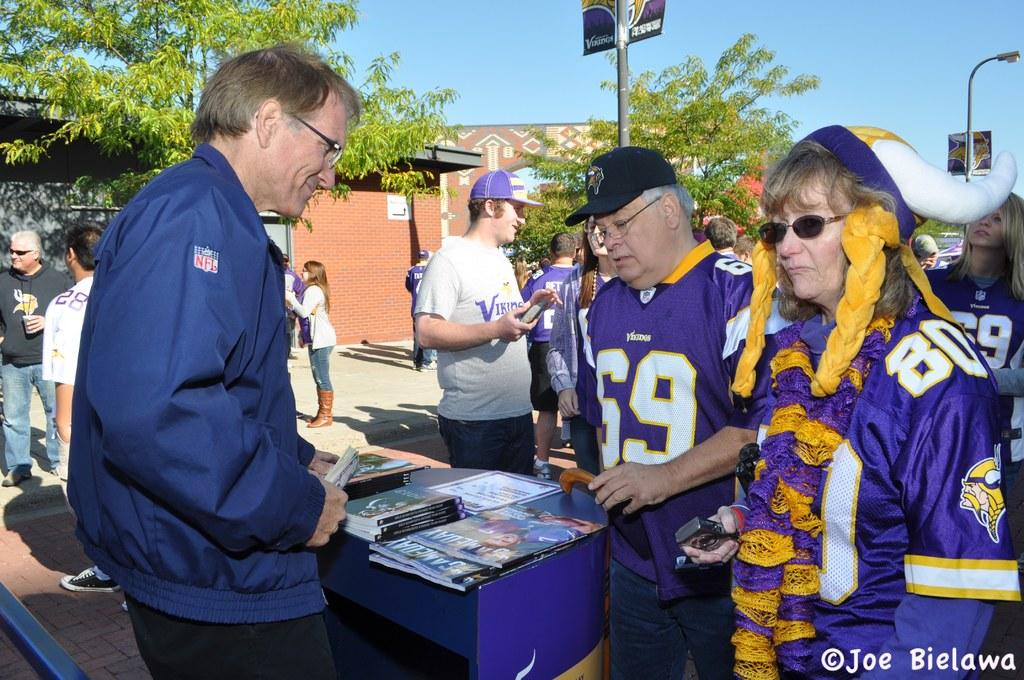What jersey number is on the woman's sleeve?
Your answer should be very brief. 80. 